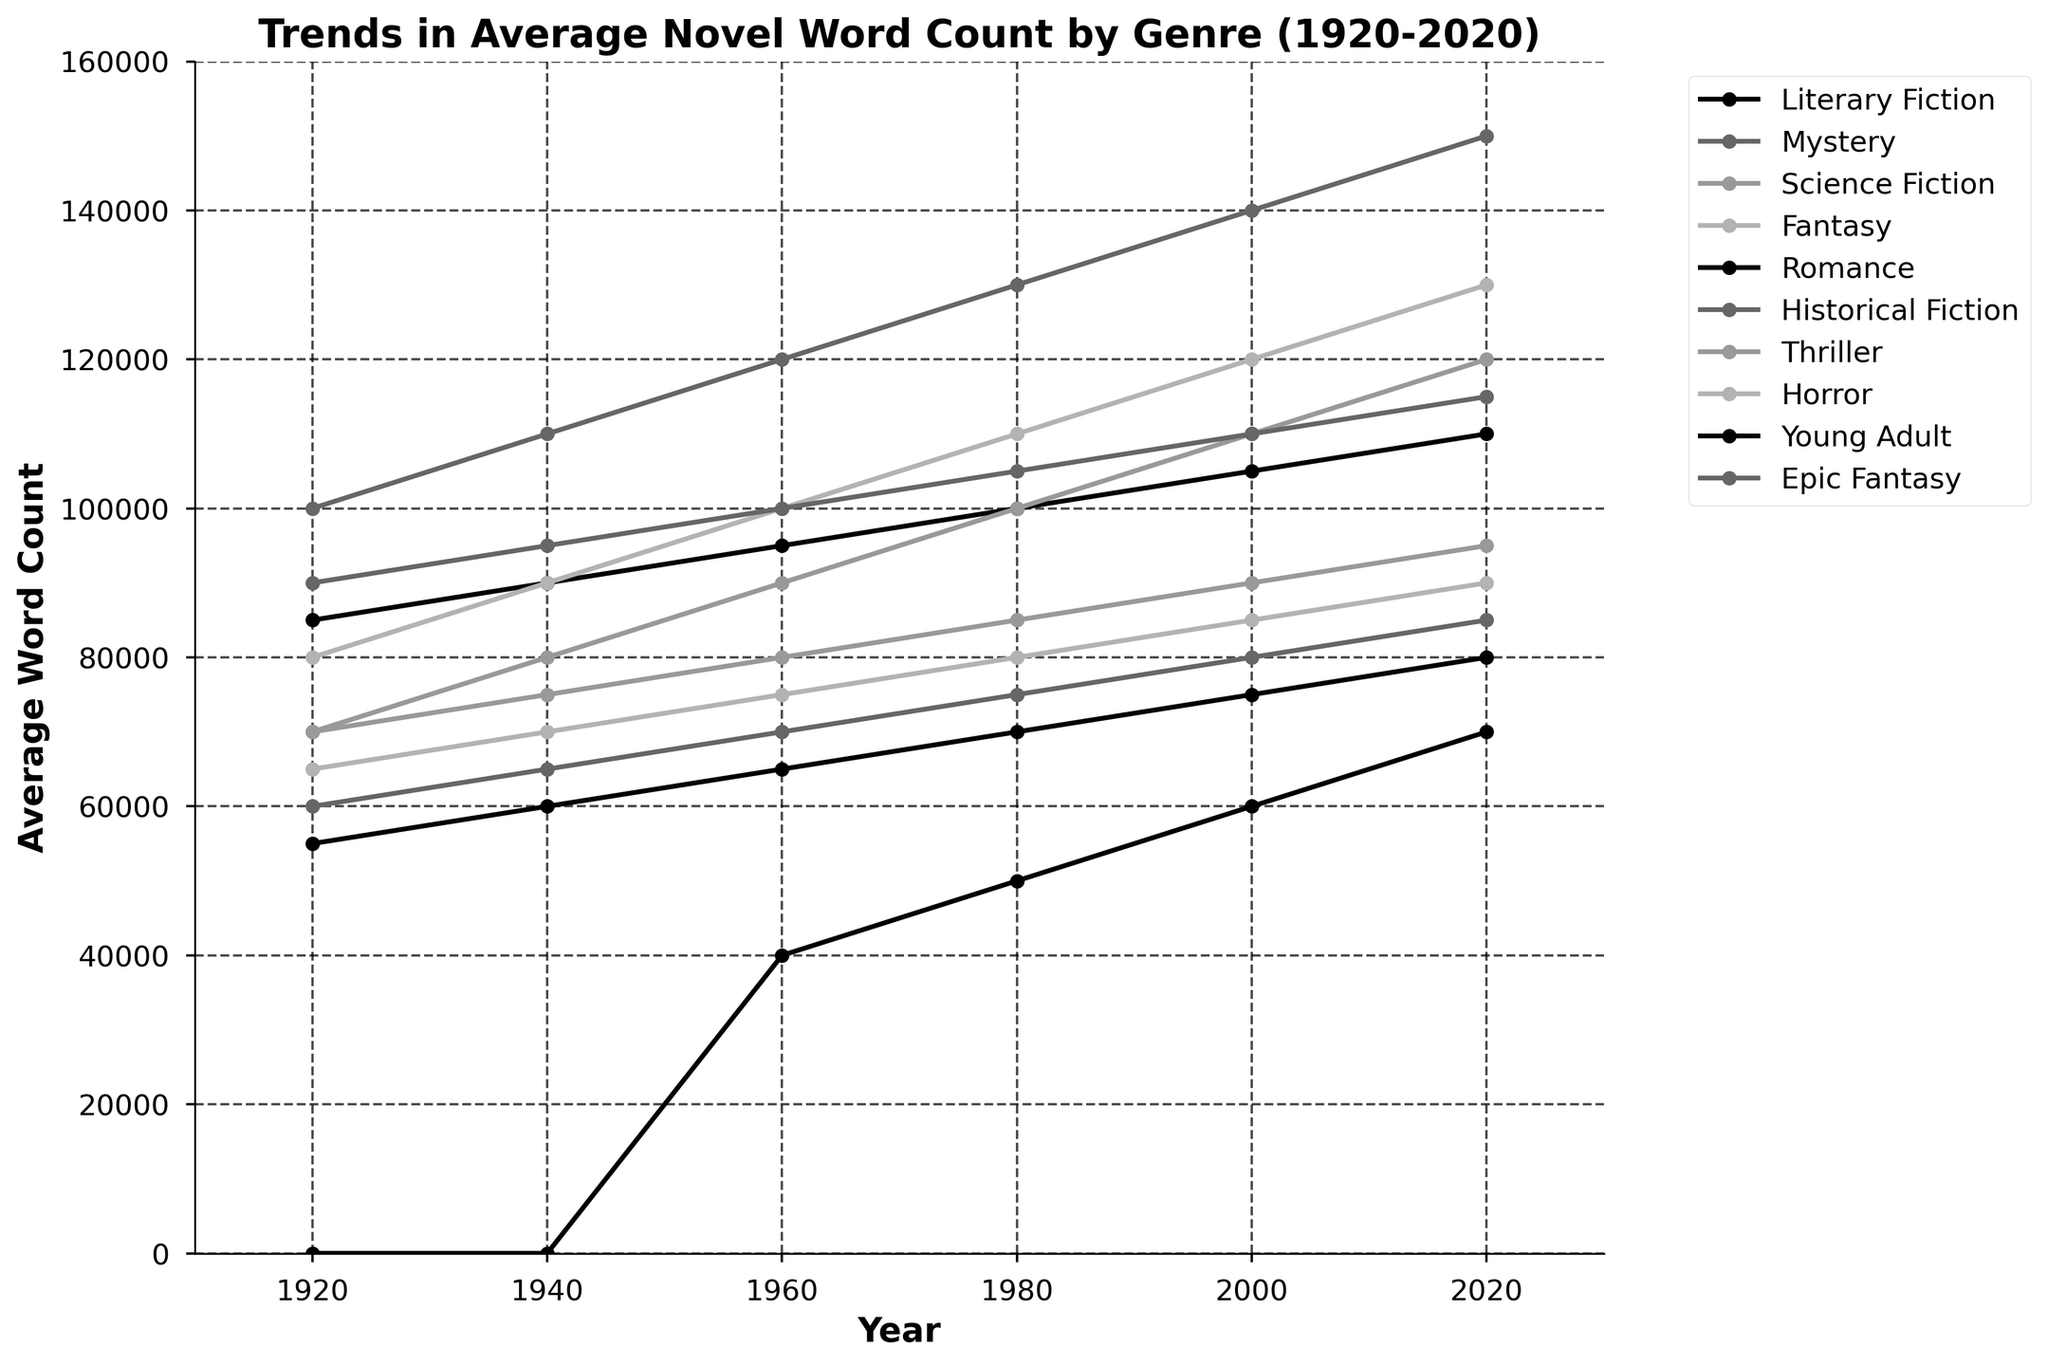What trend can be observed in the average word count for Fantasy novels from 1920 to 2020? The average word count for Fantasy novels shows a consistent upward trend from 1920 to 2020. The word count increases roughly every 20 years.
Answer: Increasing trend Between 1920 and 2020, which genre had the greatest overall increase in average word count? To find the genre with the greatest increase, subtract the word count of each genre in 1920 from its word count in 2020. Epic Fantasy saw the largest increase, from 100,000 words in 1920 to 150,000 words in 2020, an increase of 50,000 words.
Answer: Epic Fantasy Which genre had the lowest average word count in 2020? Looking at the data for 2020, Romance novels had the lowest average word count at 80,000 words.
Answer: Romance How many genres had an average word count of over 100,000 words in 2020? From the figure, Literary Fiction, Science Fiction, Fantasy, Historical Fiction, Epic Fantasy all exceed 100,000 words in 2020. Counting these genres, we get 5 genres.
Answer: 5 In which period did Young Adult novels see their most significant increase in word count? Young Adult novels are introduced in the 1960s, with a dramatic increase from 40,000 words in 1960 to 70,000 words in 2020, most notably between 1980 and 2000.
Answer: 1980 to 2000 Compare the average word count for Mystery novels in 1980 and Historical Fiction novels in the same year. Which is higher? The average word count for Mystery novels in 1980 is 75,000 words, while for Historical Fiction novels it's 105,000 words. Historical Fiction is higher by 30,000 words.
Answer: Historical Fiction Which genres show a continuous increase in word count every 20 years from 1920 to 2020? Genres with continuous increases every 20 years are Literary Fiction, Science Fiction, Fantasy, Historical Fiction, Thriller, Horror, and Epic Fantasy.
Answer: Literary Fiction, Science Fiction, Fantasy, Historical Fiction, Thriller, Horror, Epic Fantasy What is the average word count of Romance novels over the given years? Add up the word counts for Romance novels in provided years (55,000+60,000+65,000+70,000+75,000+80,000) which equals 405,000, and divide by number of years (6). The average is 405,000/6.
Answer: 67,500 Between 1940 and 1980, which genre saw the most significant increase in average word count? The most significant increase happened in Historical Fiction, which went from 95,000 to 105,000 words, an increase of 10,000 words.
Answer: Historical Fiction 